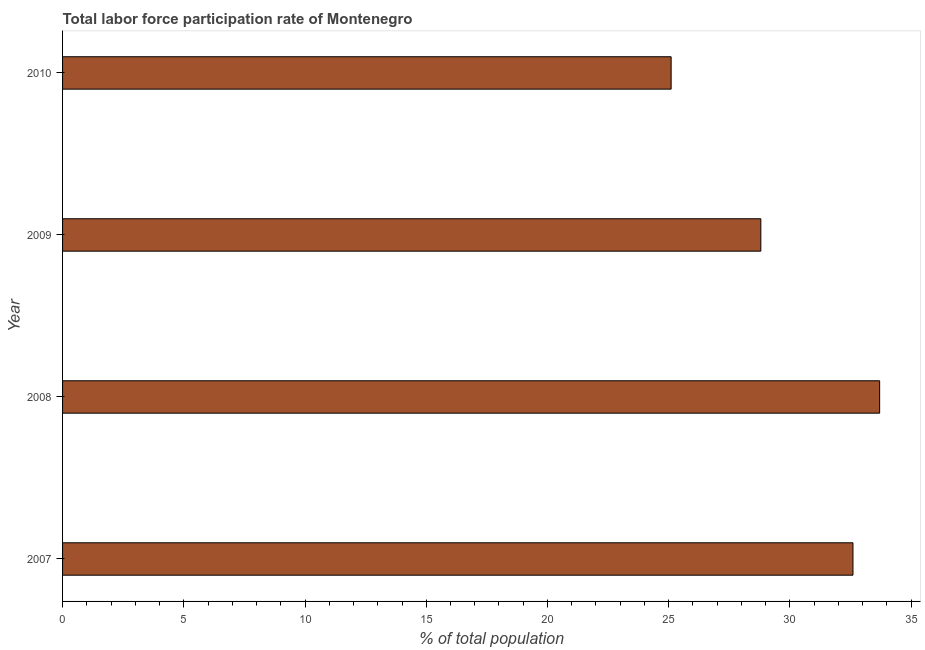Does the graph contain any zero values?
Your response must be concise. No. Does the graph contain grids?
Give a very brief answer. No. What is the title of the graph?
Provide a short and direct response. Total labor force participation rate of Montenegro. What is the label or title of the X-axis?
Give a very brief answer. % of total population. What is the total labor force participation rate in 2007?
Offer a very short reply. 32.6. Across all years, what is the maximum total labor force participation rate?
Provide a succinct answer. 33.7. Across all years, what is the minimum total labor force participation rate?
Provide a short and direct response. 25.1. What is the sum of the total labor force participation rate?
Ensure brevity in your answer.  120.2. What is the difference between the total labor force participation rate in 2007 and 2009?
Make the answer very short. 3.8. What is the average total labor force participation rate per year?
Your answer should be compact. 30.05. What is the median total labor force participation rate?
Your response must be concise. 30.7. Do a majority of the years between 2009 and 2007 (inclusive) have total labor force participation rate greater than 9 %?
Offer a terse response. Yes. What is the ratio of the total labor force participation rate in 2007 to that in 2009?
Offer a very short reply. 1.13. Is the total labor force participation rate in 2008 less than that in 2010?
Your answer should be compact. No. Is the difference between the total labor force participation rate in 2009 and 2010 greater than the difference between any two years?
Your answer should be very brief. No. Is the sum of the total labor force participation rate in 2008 and 2009 greater than the maximum total labor force participation rate across all years?
Your answer should be compact. Yes. In how many years, is the total labor force participation rate greater than the average total labor force participation rate taken over all years?
Make the answer very short. 2. How many bars are there?
Offer a terse response. 4. Are all the bars in the graph horizontal?
Offer a terse response. Yes. How many years are there in the graph?
Provide a succinct answer. 4. Are the values on the major ticks of X-axis written in scientific E-notation?
Ensure brevity in your answer.  No. What is the % of total population in 2007?
Provide a succinct answer. 32.6. What is the % of total population of 2008?
Make the answer very short. 33.7. What is the % of total population of 2009?
Ensure brevity in your answer.  28.8. What is the % of total population in 2010?
Your response must be concise. 25.1. What is the difference between the % of total population in 2007 and 2008?
Your answer should be very brief. -1.1. What is the difference between the % of total population in 2007 and 2009?
Keep it short and to the point. 3.8. What is the difference between the % of total population in 2008 and 2010?
Your answer should be very brief. 8.6. What is the ratio of the % of total population in 2007 to that in 2008?
Your answer should be very brief. 0.97. What is the ratio of the % of total population in 2007 to that in 2009?
Your response must be concise. 1.13. What is the ratio of the % of total population in 2007 to that in 2010?
Offer a very short reply. 1.3. What is the ratio of the % of total population in 2008 to that in 2009?
Keep it short and to the point. 1.17. What is the ratio of the % of total population in 2008 to that in 2010?
Offer a very short reply. 1.34. What is the ratio of the % of total population in 2009 to that in 2010?
Your answer should be compact. 1.15. 